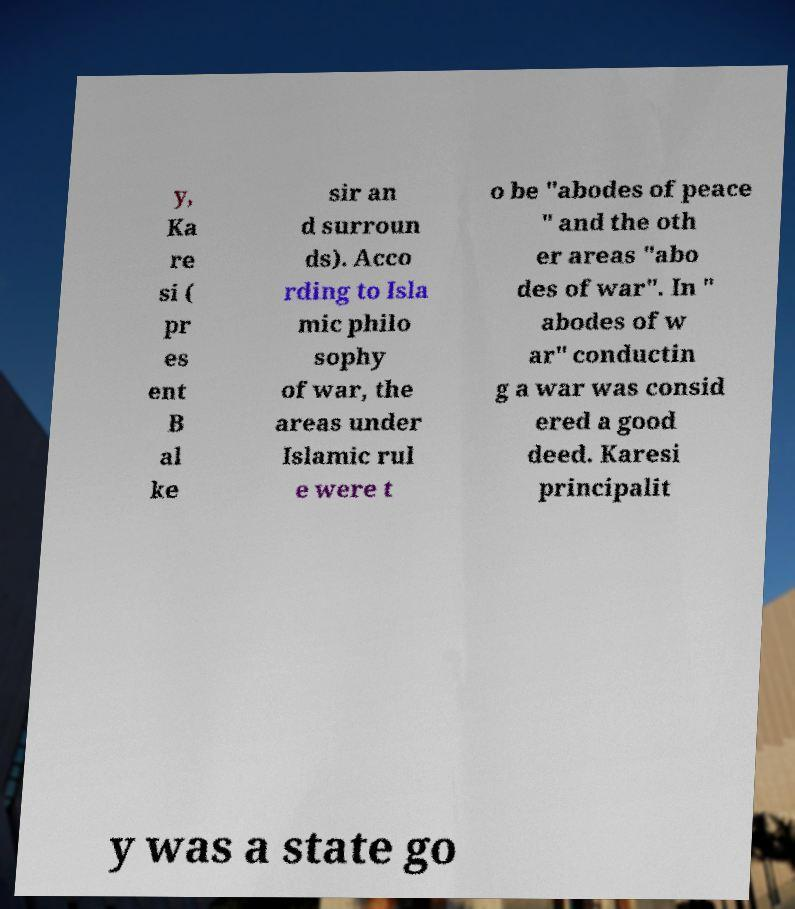I need the written content from this picture converted into text. Can you do that? y, Ka re si ( pr es ent B al ke sir an d surroun ds). Acco rding to Isla mic philo sophy of war, the areas under Islamic rul e were t o be "abodes of peace " and the oth er areas "abo des of war". In " abodes of w ar" conductin g a war was consid ered a good deed. Karesi principalit y was a state go 